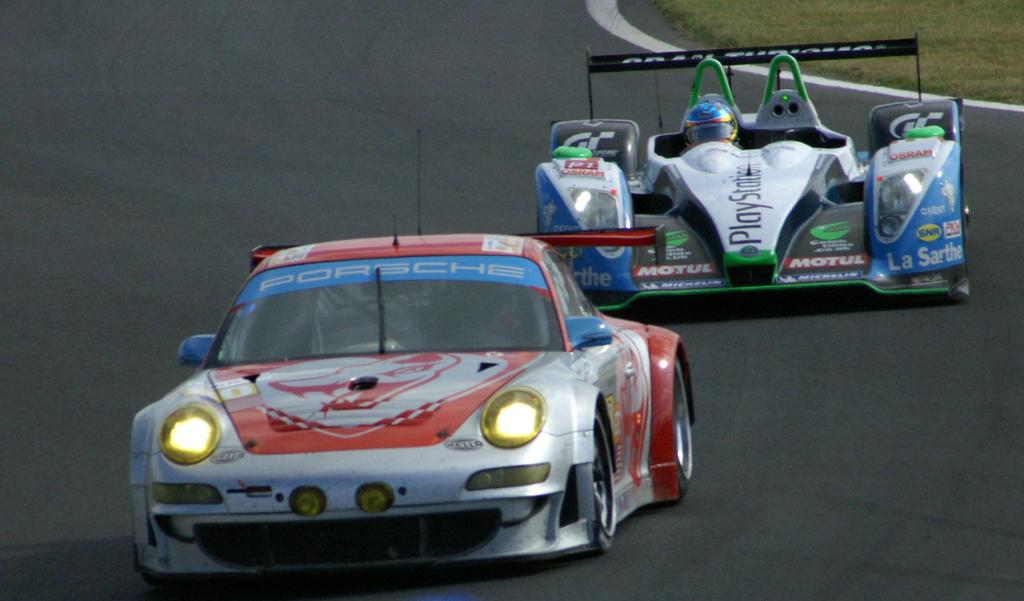What are the main subjects in the image? There are two racing cars in the image. Where are the racing cars located? The racing cars are on a road. What type of vegetation can be seen in the image? There is grass visible in the top right corner of the image. What type of watch is the snail wearing in the image? There are no snails or watches present in the image; it features two racing cars on a road. What material is the wool used for in the image? There is no wool present in the image. 